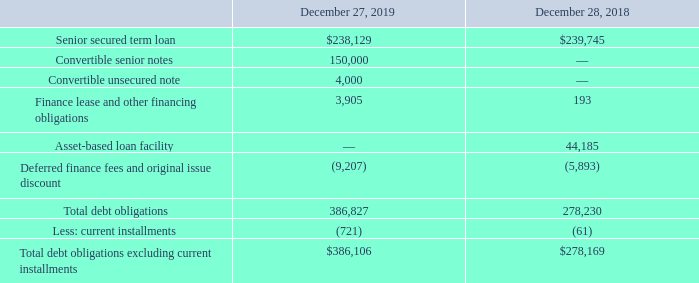Note 9 – Debt Obligations
Debt obligations as of December 27, 2019 and December 28, 2018 consisted of the following:
Senior Secured Term Loan Credit Facility
On June 22, 2016, the Company refinanced its debt structure by entering into a credit agreement (the “Term Loan Credit Agreement”) with a group of lenders for which Jefferies Finance LLC acts as administrative agent and collateral agent. The Term Loan Credit Agreement provides for a senior secured term loan B facility (the “Term Loan Facility”) in an aggregate amount of $305,000 (the loans outstanding under the Term Loan Facility, the “Term Loans”) maturing on June 22, 2022. Additionally, the Term Loan Facility includes an accordion which permits the Company to request that the lenders extend additional Term Loans in an aggregate principal amount of up to $50,000 (less the aggregate amount of certain indebtedness incurred to finance acquisitions) plus an unlimited amount subject to the Company’s Total Leverage Ratio not exceeding 4.90:1.00 on a pro forma basis. Borrowings were used to repay the Company’s senior secured notes, as well as the prior term loan and revolving credit facility. Remaining funds were used for capital expenditures, permitted acquisitions, working capital and general corporate purposes of the Company.
On December 13, 2017, the Company completed a repricing of the Term Loan Facility to reduce Applicable Rate (as defined in the Term Loan Credit Agreement) from 475 basis points to 400 basis points over the London Inter-bank Offered Rate (“LIBOR”). In connection with the repricing, the Company paid debt financing costs of $761 which were capitalized as deferred financing charges.
On July 6, 2018, the Company made a $47,100 prepayment and is no longer required to make quarterly amortization payments on the Term Loans. On November 16, 2018, the Company completed a repricing of the Term Loan Facility to reduce the Applicable Rate from 400 basis points to 350 basis points over LIBOR. In connection with the repricing, the Company paid debt financing costs of $626 which were capitalized as deferred financing charges. The Company wrote off unamortized deferred financing fees of $1,081 as a result of this repricing.
The interest charged on the Term Loans, will be equal to a spread plus, at the Company’s option, either the Base Rate (as defined in the Term Loan Credit Agreement) or LIBOR for one, two, three, six or (if consented to by the lenders) twelve-month interest periods chosen by the Company. The interest rate on the Term Loans at December 27, 2019 was 5.2%.
The Term Loan Facility contains customary affirmative covenants, negative covenants (including restrictions, subject to customary exceptions, on incurring debt or liens, paying dividends, repaying payment subordinated and junior lien debt, disposing assets, and making investments and acquisitions), and events of default for a term loan B facility of this type, as more particularly described in the Term Loan Credit Agreement. As of December 27, 2019, the Company was in compliance with all debt covenants under the Term Loan Credit Agreement.
Asset-Based Loan Facility
On June 29, 2018, the Company entered into a credit agreement (the “ABL Credit Agreement”) with a group of lenders for which BMO Harris Bank, N.A. acts as administrative agent. The ABL Credit Agreement provides for an asset-based loan facility (the “ABL”) in the aggregate amount of up to $150,000. Borrowings under the ABL will be used, and are expected to be used, for capital expenditures, permitted acquisitions, working capital and general corporate purposes of the Company. Availability under the ABL will be limited to a borrowing base equal to the lesser of: (i) the aggregate amount of commitments or (ii) the sum of specified percentages of eligible receivables and eligible inventory, minus certain availability reserves. The co-borrowers under the ABL are entitled on one or more occasions, subject to the satisfaction of certain conditions, to request an increase in the commitments under the ABL in an aggregate principal amount of up to $25,000. The ABL matures on the earlier of June 29, 2023 and 90 days prior to the maturity date of the Company’s Term Loan Facility.
The interest rate charged on borrowing under the ABL is equal to a spread plus, at the Company’s option, either the Base Rate (as defined in the ABL Credit Agreement) or LIBOR (except for swingline loans) for one, two, three, six or (if consented to by the lenders) twelve-month, interest periods chosen by the Company. The Company will pay certain recurring fees with respect to the ABL, including fees on unused lender commitments.
The ABL Credit Agreement contains customary affirmative covenants, negative covenants and events of default as more particularly described in the ABL Credit Agreement. The Company is required to comply with a minimum consolidated fixed charge coverage ratio of 1:1 if the amount of availability under the ABL falls below $10,000 or 10% of the borrowing base.
The Company incurred transaction costs of $877 which were capitalized as deferred financing fees to be amortized over the term of the ABL. On July 6, 2018, the Company borrowed $47,100 under the ABL and made an equivalent prepayment on its Term Loans. On November 22, 2019, the Company fully paid all borrowings outstanding under the ABL and there was no balance outstanding as of December 27, 2019. The weighted average interest rate on our ABL borrowings was approximately 3.7% during fiscal 2019.
As of December 27, 2019, the Company was in compliance with all debt covenants and the Company had reserved $16,641 of the ABL for the issuance of letters of credit. As of December 27, 2019, funds totaling $133,359 were available for borrowing under the ABL.
Convertible Senior Notes
On November 22, 2019, the Company issued $150,000 aggregate principal amount of 1.875% Convertible Senior Notes (the “Senior Notes”). The Senior Notes were issued pursuant to an indenture, dated as of November 22, 2019 (the “Indenture”), between the Company and The Bank of New York Mellon Trust Company, N.A., as trustee. Approximately $43,225 of the net proceeds were used to repay all outstanding borrowings under the ABL and the Company intends to use the remainder for working capital and general corporate purposes, which may include future acquisitions.
The Senior Notes bear interest of 1.875% per annum payable semiannually in arrears on June 1 and December 1 of each year, beginning on June 1, 2020. At any time before the close of business on the scheduled trading day immediately before the maturity date, the Senior Notes will be convertible at the option of holders into shares of the Company’s common stock, together with cash in lieu of any fractional share, at an initial conversion price of approximately $44.20 per share. The conversion price is subject to adjustments upon the occurrence of certain events. The Senior Notes will mature on December 1, 2024, unless earlier converted or repurchased in accordance with their terms.
The Company may not redeem the Senior Notes at its option prior to maturity. In addition, if the Company undergoes a fundamental change, as described in the Indenture, holders may require the Company to repurchase for cash all or part of their Senior Notes at a repurchase price equal to 100% of the principal amount of the Senior Notes to be repurchased, plus accrued and unpaid interest up to, but excluding, the required repurchase date.
The Company incurred transaction costs of approximately $5,082 which were capitalized as deferred financing fees to be amortized over the term of the Senior Notes.
Convertible Unsecured Note
On February 25, 2019, the Company issued a $4,000 convertible unsecured note (the “Unsecured Note”), maturing on June 29, 2023, to Bassian Farms, Inc. (the “Holder”) as partial consideration in the Bassian acquisition. The interest rate charged on the Unsecured Note is 4.5% per annum and increases to 5.0% after the two-year anniversary of the closing date. The Company may, in certain instances beginning eighteen months after issuance of the Unsecured Note, redeem the Unsecured Note in whole or in part for cash or convert the Unsecured Note into shares of the Company’s common stock at the conversion price of $43.93 per share. After the two-year anniversary of the closing date, the Holder may convert the Unsecured Note into shares of the Company’s common stock at the conversion price. Upon a change of control event, the Holder may convert the Unsecured Note into shares of the Company’s common stock at the conversion price or redeem the Unsecured Note for cash.
What is the Senior secured term loan in 2019 and 2018 respectively? $238,129, $239,745. What is the Total debt obligations in 2019 and 2018 respectively? 386,827, 278,230. What is the Total debt obligations excluding current installments in 2019 and 2018 respectively? $386,106, $278,169. What is the average Senior secured term loan for 2018 and 2019? (238,129+ 239,745)/2
Answer: 238937. Which year has the highest Senior secured term loan? 239,745> 238,129
Answer: 2018. What is the change in the value of Finance lease and other financing obligations between 2018 and 2019? 3,905-193
Answer: 3712. 